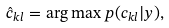Convert formula to latex. <formula><loc_0><loc_0><loc_500><loc_500>\hat { c } _ { k l } = \arg \max p ( c _ { k l } | y ) ,</formula> 